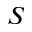<formula> <loc_0><loc_0><loc_500><loc_500>S</formula> 